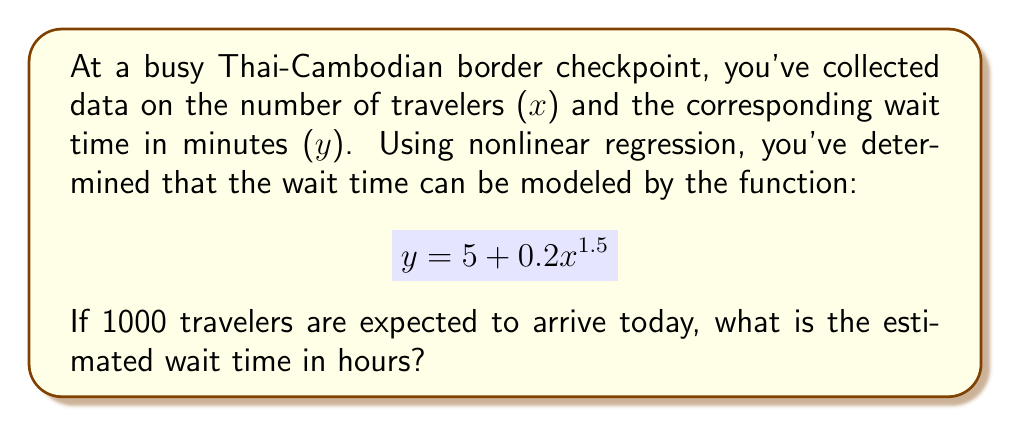Could you help me with this problem? To solve this problem, we'll follow these steps:

1) We're given the nonlinear regression model:
   $$y = 5 + 0.2x^{1.5}$$
   where y is the wait time in minutes and x is the number of travelers.

2) We need to find y when x = 1000:
   $$y = 5 + 0.2(1000)^{1.5}$$

3) Let's calculate this step-by-step:
   a) First, calculate $1000^{1.5}$:
      $$1000^{1.5} = 1000 \times \sqrt{1000} = 1000 \times 31.6228 = 31622.8$$

   b) Now, multiply this by 0.2:
      $$0.2 \times 31622.8 = 6324.56$$

   c) Add 5 to this result:
      $$5 + 6324.56 = 6329.56$$

4) So, the wait time is approximately 6329.56 minutes.

5) To convert this to hours, divide by 60:
   $$\frac{6329.56}{60} = 105.4927$$

Therefore, the estimated wait time is approximately 105.49 hours.
Answer: 105.49 hours 